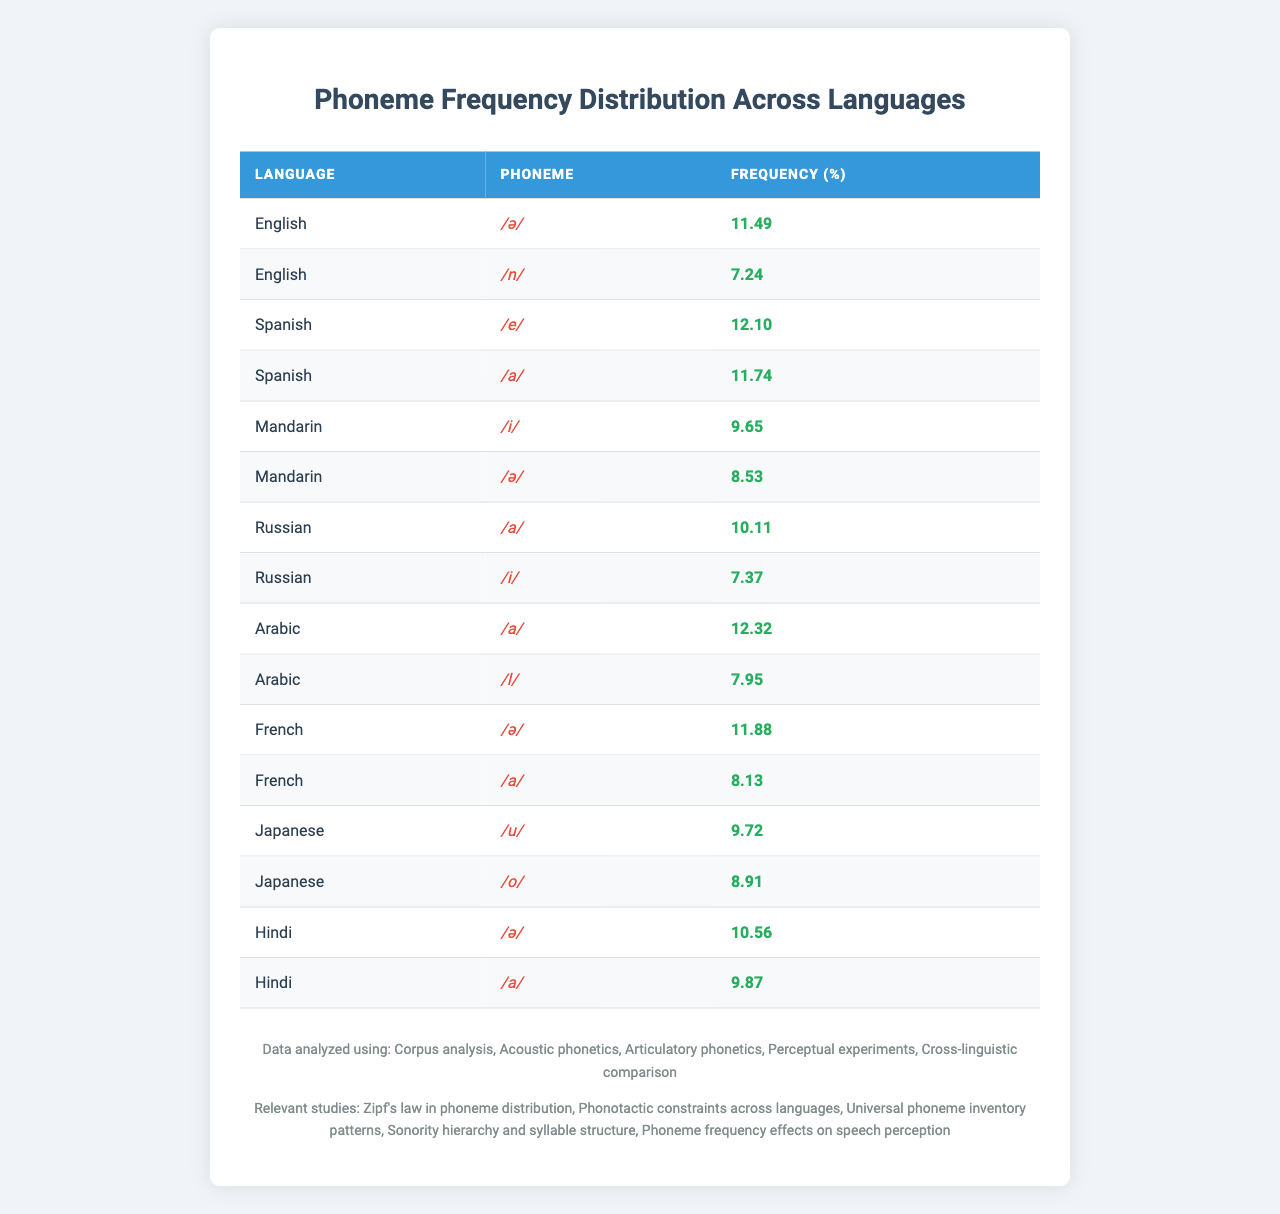What is the most frequently used phoneme in English? The table shows that the highest frequency for any phoneme in English is for /ə/, which has a frequency of 11.49%.
Answer: /ə/ Which phoneme has the highest frequency in Arabic? According to the table, the highest frequency for phonemes in Arabic is /a/, with a frequency of 12.32%.
Answer: /a/ How many languages have the phoneme /a/? The languages listed in the table that contain the phoneme /a/ are Spanish, Russian, Arabic, French, and Hindi. This totals to five languages.
Answer: 5 What is the average frequency of the phoneme /i/ across the languages it appears in? The phoneme /i/ appears in English (7.24%), Mandarin (9.65%), Russian (7.37%), and is not present in other languages. Adding these frequencies gives us 24.26%, and dividing by 3 gives an average of 8.09%.
Answer: 8.09% Is the frequency of /o/ in Japanese higher than the frequency of /u/ in Japanese? In the table, /o/ has a frequency of 8.91%, and /u/ has a frequency of 9.72%. Since 9.72% is greater than 8.91%, the statement is false.
Answer: No Which phoneme appears with the highest frequency in Mandarin, and how does it compare to the frequency of /i/ in the same language? The phoneme with the highest frequency in Mandarin is /i/, which has a frequency of 9.65%, while /ə/ has a frequency of 8.53%. Thus, /i/ is more frequent than /ə/ by 1.12%.
Answer: /i/ What is the total frequency of phonemes used in Spanish? The frequencies for Spanish phonemes are /e/ (12.10%) and /a/ (11.74%). Adding these together, the total frequency is 23.84%.
Answer: 23.84% Are there any languages where the phoneme /ə/ has a frequency lower than 8%? From the table, the frequencies for /ə/ are: English (11.49%), Mandarin (8.53%), and Hindi (10.56%). The lowest frequency for /ə/ is still above 8%, so the answer is no.
Answer: No What is the difference in frequency between the phonemes /a/ in Arabic and Hindi? The frequency of /a/ in Arabic is 12.32%, while in Hindi it’s 9.87%. The difference is 12.32% - 9.87% = 2.45%.
Answer: 2.45% Which language has the second highest frequency of the phoneme /a/? Arabic has the highest frequency for /a/ at 12.32%, and the second highest frequency for /a/ is in Russian at 10.11%.
Answer: Russian 